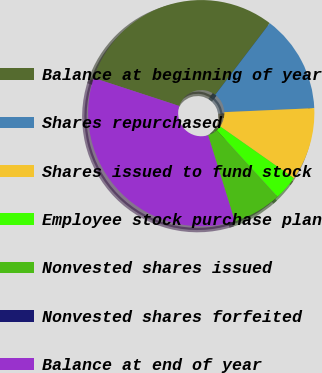<chart> <loc_0><loc_0><loc_500><loc_500><pie_chart><fcel>Balance at beginning of year<fcel>Shares repurchased<fcel>Shares issued to fund stock<fcel>Employee stock purchase plan<fcel>Nonvested shares issued<fcel>Nonvested shares forfeited<fcel>Balance at end of year<nl><fcel>30.32%<fcel>13.94%<fcel>10.45%<fcel>3.49%<fcel>6.97%<fcel>0.0%<fcel>34.83%<nl></chart> 